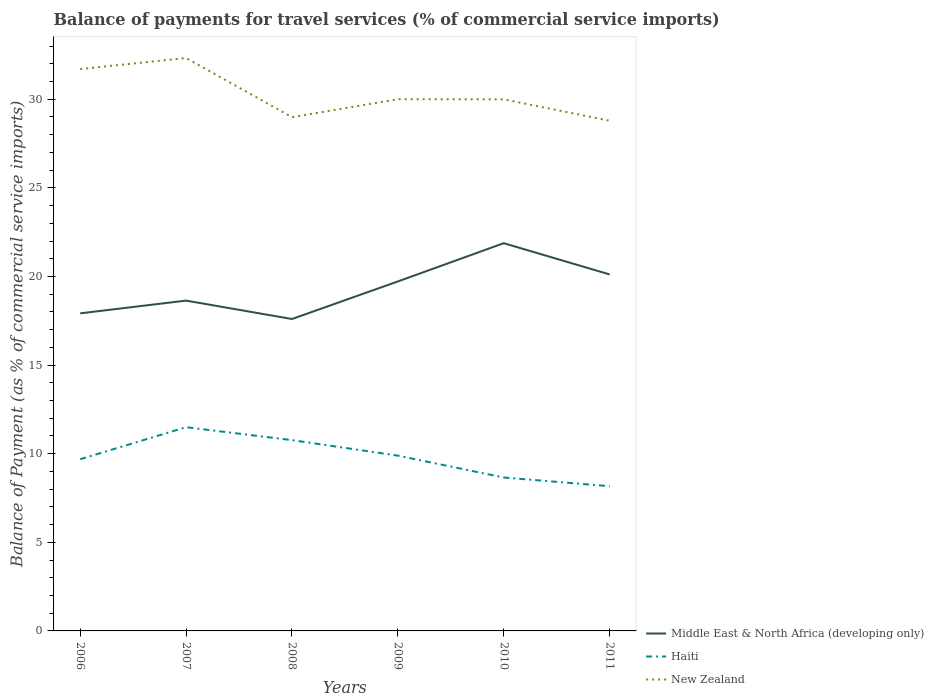How many different coloured lines are there?
Offer a terse response. 3. Is the number of lines equal to the number of legend labels?
Your response must be concise. Yes. Across all years, what is the maximum balance of payments for travel services in New Zealand?
Your answer should be compact. 28.78. What is the total balance of payments for travel services in Haiti in the graph?
Provide a short and direct response. 2.11. What is the difference between the highest and the second highest balance of payments for travel services in New Zealand?
Keep it short and to the point. 3.54. What is the difference between the highest and the lowest balance of payments for travel services in Haiti?
Ensure brevity in your answer.  3. Is the balance of payments for travel services in Haiti strictly greater than the balance of payments for travel services in New Zealand over the years?
Offer a terse response. Yes. How many years are there in the graph?
Make the answer very short. 6. What is the difference between two consecutive major ticks on the Y-axis?
Offer a very short reply. 5. Does the graph contain any zero values?
Your answer should be very brief. No. How many legend labels are there?
Provide a short and direct response. 3. What is the title of the graph?
Your answer should be compact. Balance of payments for travel services (% of commercial service imports). What is the label or title of the Y-axis?
Offer a terse response. Balance of Payment (as % of commercial service imports). What is the Balance of Payment (as % of commercial service imports) of Middle East & North Africa (developing only) in 2006?
Keep it short and to the point. 17.92. What is the Balance of Payment (as % of commercial service imports) in Haiti in 2006?
Your response must be concise. 9.69. What is the Balance of Payment (as % of commercial service imports) in New Zealand in 2006?
Make the answer very short. 31.7. What is the Balance of Payment (as % of commercial service imports) in Middle East & North Africa (developing only) in 2007?
Give a very brief answer. 18.64. What is the Balance of Payment (as % of commercial service imports) of Haiti in 2007?
Your response must be concise. 11.49. What is the Balance of Payment (as % of commercial service imports) of New Zealand in 2007?
Your response must be concise. 32.33. What is the Balance of Payment (as % of commercial service imports) in Middle East & North Africa (developing only) in 2008?
Offer a terse response. 17.6. What is the Balance of Payment (as % of commercial service imports) of Haiti in 2008?
Ensure brevity in your answer.  10.77. What is the Balance of Payment (as % of commercial service imports) of New Zealand in 2008?
Your response must be concise. 28.99. What is the Balance of Payment (as % of commercial service imports) of Middle East & North Africa (developing only) in 2009?
Your answer should be very brief. 19.72. What is the Balance of Payment (as % of commercial service imports) in Haiti in 2009?
Your answer should be compact. 9.89. What is the Balance of Payment (as % of commercial service imports) in New Zealand in 2009?
Make the answer very short. 30. What is the Balance of Payment (as % of commercial service imports) of Middle East & North Africa (developing only) in 2010?
Your answer should be very brief. 21.88. What is the Balance of Payment (as % of commercial service imports) in Haiti in 2010?
Provide a succinct answer. 8.66. What is the Balance of Payment (as % of commercial service imports) in New Zealand in 2010?
Your response must be concise. 29.99. What is the Balance of Payment (as % of commercial service imports) in Middle East & North Africa (developing only) in 2011?
Keep it short and to the point. 20.11. What is the Balance of Payment (as % of commercial service imports) of Haiti in 2011?
Make the answer very short. 8.16. What is the Balance of Payment (as % of commercial service imports) of New Zealand in 2011?
Your answer should be compact. 28.78. Across all years, what is the maximum Balance of Payment (as % of commercial service imports) in Middle East & North Africa (developing only)?
Give a very brief answer. 21.88. Across all years, what is the maximum Balance of Payment (as % of commercial service imports) of Haiti?
Offer a terse response. 11.49. Across all years, what is the maximum Balance of Payment (as % of commercial service imports) of New Zealand?
Offer a very short reply. 32.33. Across all years, what is the minimum Balance of Payment (as % of commercial service imports) in Middle East & North Africa (developing only)?
Offer a terse response. 17.6. Across all years, what is the minimum Balance of Payment (as % of commercial service imports) in Haiti?
Provide a short and direct response. 8.16. Across all years, what is the minimum Balance of Payment (as % of commercial service imports) of New Zealand?
Make the answer very short. 28.78. What is the total Balance of Payment (as % of commercial service imports) of Middle East & North Africa (developing only) in the graph?
Offer a terse response. 115.86. What is the total Balance of Payment (as % of commercial service imports) of Haiti in the graph?
Ensure brevity in your answer.  58.66. What is the total Balance of Payment (as % of commercial service imports) in New Zealand in the graph?
Your answer should be very brief. 181.79. What is the difference between the Balance of Payment (as % of commercial service imports) in Middle East & North Africa (developing only) in 2006 and that in 2007?
Ensure brevity in your answer.  -0.72. What is the difference between the Balance of Payment (as % of commercial service imports) of Haiti in 2006 and that in 2007?
Your answer should be very brief. -1.81. What is the difference between the Balance of Payment (as % of commercial service imports) in New Zealand in 2006 and that in 2007?
Your answer should be compact. -0.63. What is the difference between the Balance of Payment (as % of commercial service imports) of Middle East & North Africa (developing only) in 2006 and that in 2008?
Offer a terse response. 0.32. What is the difference between the Balance of Payment (as % of commercial service imports) of Haiti in 2006 and that in 2008?
Your answer should be compact. -1.08. What is the difference between the Balance of Payment (as % of commercial service imports) in New Zealand in 2006 and that in 2008?
Provide a short and direct response. 2.71. What is the difference between the Balance of Payment (as % of commercial service imports) in Middle East & North Africa (developing only) in 2006 and that in 2009?
Your answer should be compact. -1.8. What is the difference between the Balance of Payment (as % of commercial service imports) of Haiti in 2006 and that in 2009?
Provide a succinct answer. -0.2. What is the difference between the Balance of Payment (as % of commercial service imports) in New Zealand in 2006 and that in 2009?
Offer a very short reply. 1.7. What is the difference between the Balance of Payment (as % of commercial service imports) in Middle East & North Africa (developing only) in 2006 and that in 2010?
Your answer should be compact. -3.96. What is the difference between the Balance of Payment (as % of commercial service imports) in Haiti in 2006 and that in 2010?
Offer a terse response. 1.03. What is the difference between the Balance of Payment (as % of commercial service imports) of New Zealand in 2006 and that in 2010?
Give a very brief answer. 1.71. What is the difference between the Balance of Payment (as % of commercial service imports) of Middle East & North Africa (developing only) in 2006 and that in 2011?
Offer a very short reply. -2.19. What is the difference between the Balance of Payment (as % of commercial service imports) in Haiti in 2006 and that in 2011?
Offer a terse response. 1.52. What is the difference between the Balance of Payment (as % of commercial service imports) in New Zealand in 2006 and that in 2011?
Your answer should be compact. 2.92. What is the difference between the Balance of Payment (as % of commercial service imports) of Middle East & North Africa (developing only) in 2007 and that in 2008?
Your answer should be very brief. 1.04. What is the difference between the Balance of Payment (as % of commercial service imports) of Haiti in 2007 and that in 2008?
Your response must be concise. 0.73. What is the difference between the Balance of Payment (as % of commercial service imports) in New Zealand in 2007 and that in 2008?
Offer a terse response. 3.34. What is the difference between the Balance of Payment (as % of commercial service imports) in Middle East & North Africa (developing only) in 2007 and that in 2009?
Your answer should be very brief. -1.08. What is the difference between the Balance of Payment (as % of commercial service imports) in Haiti in 2007 and that in 2009?
Keep it short and to the point. 1.6. What is the difference between the Balance of Payment (as % of commercial service imports) in New Zealand in 2007 and that in 2009?
Your answer should be very brief. 2.33. What is the difference between the Balance of Payment (as % of commercial service imports) of Middle East & North Africa (developing only) in 2007 and that in 2010?
Keep it short and to the point. -3.24. What is the difference between the Balance of Payment (as % of commercial service imports) in Haiti in 2007 and that in 2010?
Offer a terse response. 2.84. What is the difference between the Balance of Payment (as % of commercial service imports) of New Zealand in 2007 and that in 2010?
Keep it short and to the point. 2.33. What is the difference between the Balance of Payment (as % of commercial service imports) in Middle East & North Africa (developing only) in 2007 and that in 2011?
Make the answer very short. -1.48. What is the difference between the Balance of Payment (as % of commercial service imports) in Haiti in 2007 and that in 2011?
Give a very brief answer. 3.33. What is the difference between the Balance of Payment (as % of commercial service imports) of New Zealand in 2007 and that in 2011?
Offer a very short reply. 3.54. What is the difference between the Balance of Payment (as % of commercial service imports) in Middle East & North Africa (developing only) in 2008 and that in 2009?
Ensure brevity in your answer.  -2.12. What is the difference between the Balance of Payment (as % of commercial service imports) of Haiti in 2008 and that in 2009?
Your answer should be very brief. 0.88. What is the difference between the Balance of Payment (as % of commercial service imports) of New Zealand in 2008 and that in 2009?
Provide a short and direct response. -1.01. What is the difference between the Balance of Payment (as % of commercial service imports) of Middle East & North Africa (developing only) in 2008 and that in 2010?
Offer a terse response. -4.28. What is the difference between the Balance of Payment (as % of commercial service imports) of Haiti in 2008 and that in 2010?
Offer a terse response. 2.11. What is the difference between the Balance of Payment (as % of commercial service imports) of New Zealand in 2008 and that in 2010?
Make the answer very short. -1.01. What is the difference between the Balance of Payment (as % of commercial service imports) in Middle East & North Africa (developing only) in 2008 and that in 2011?
Make the answer very short. -2.51. What is the difference between the Balance of Payment (as % of commercial service imports) of Haiti in 2008 and that in 2011?
Your answer should be compact. 2.6. What is the difference between the Balance of Payment (as % of commercial service imports) of New Zealand in 2008 and that in 2011?
Give a very brief answer. 0.2. What is the difference between the Balance of Payment (as % of commercial service imports) in Middle East & North Africa (developing only) in 2009 and that in 2010?
Your answer should be very brief. -2.16. What is the difference between the Balance of Payment (as % of commercial service imports) of Haiti in 2009 and that in 2010?
Make the answer very short. 1.23. What is the difference between the Balance of Payment (as % of commercial service imports) of New Zealand in 2009 and that in 2010?
Ensure brevity in your answer.  0.01. What is the difference between the Balance of Payment (as % of commercial service imports) in Middle East & North Africa (developing only) in 2009 and that in 2011?
Make the answer very short. -0.4. What is the difference between the Balance of Payment (as % of commercial service imports) of Haiti in 2009 and that in 2011?
Your response must be concise. 1.73. What is the difference between the Balance of Payment (as % of commercial service imports) of New Zealand in 2009 and that in 2011?
Your answer should be very brief. 1.22. What is the difference between the Balance of Payment (as % of commercial service imports) of Middle East & North Africa (developing only) in 2010 and that in 2011?
Your response must be concise. 1.76. What is the difference between the Balance of Payment (as % of commercial service imports) in Haiti in 2010 and that in 2011?
Offer a very short reply. 0.49. What is the difference between the Balance of Payment (as % of commercial service imports) of New Zealand in 2010 and that in 2011?
Offer a terse response. 1.21. What is the difference between the Balance of Payment (as % of commercial service imports) in Middle East & North Africa (developing only) in 2006 and the Balance of Payment (as % of commercial service imports) in Haiti in 2007?
Your answer should be very brief. 6.42. What is the difference between the Balance of Payment (as % of commercial service imports) in Middle East & North Africa (developing only) in 2006 and the Balance of Payment (as % of commercial service imports) in New Zealand in 2007?
Keep it short and to the point. -14.41. What is the difference between the Balance of Payment (as % of commercial service imports) of Haiti in 2006 and the Balance of Payment (as % of commercial service imports) of New Zealand in 2007?
Your response must be concise. -22.64. What is the difference between the Balance of Payment (as % of commercial service imports) of Middle East & North Africa (developing only) in 2006 and the Balance of Payment (as % of commercial service imports) of Haiti in 2008?
Keep it short and to the point. 7.15. What is the difference between the Balance of Payment (as % of commercial service imports) in Middle East & North Africa (developing only) in 2006 and the Balance of Payment (as % of commercial service imports) in New Zealand in 2008?
Offer a terse response. -11.07. What is the difference between the Balance of Payment (as % of commercial service imports) in Haiti in 2006 and the Balance of Payment (as % of commercial service imports) in New Zealand in 2008?
Ensure brevity in your answer.  -19.3. What is the difference between the Balance of Payment (as % of commercial service imports) of Middle East & North Africa (developing only) in 2006 and the Balance of Payment (as % of commercial service imports) of Haiti in 2009?
Offer a terse response. 8.03. What is the difference between the Balance of Payment (as % of commercial service imports) of Middle East & North Africa (developing only) in 2006 and the Balance of Payment (as % of commercial service imports) of New Zealand in 2009?
Keep it short and to the point. -12.08. What is the difference between the Balance of Payment (as % of commercial service imports) of Haiti in 2006 and the Balance of Payment (as % of commercial service imports) of New Zealand in 2009?
Your response must be concise. -20.31. What is the difference between the Balance of Payment (as % of commercial service imports) of Middle East & North Africa (developing only) in 2006 and the Balance of Payment (as % of commercial service imports) of Haiti in 2010?
Give a very brief answer. 9.26. What is the difference between the Balance of Payment (as % of commercial service imports) of Middle East & North Africa (developing only) in 2006 and the Balance of Payment (as % of commercial service imports) of New Zealand in 2010?
Your answer should be compact. -12.07. What is the difference between the Balance of Payment (as % of commercial service imports) in Haiti in 2006 and the Balance of Payment (as % of commercial service imports) in New Zealand in 2010?
Your answer should be very brief. -20.3. What is the difference between the Balance of Payment (as % of commercial service imports) of Middle East & North Africa (developing only) in 2006 and the Balance of Payment (as % of commercial service imports) of Haiti in 2011?
Provide a succinct answer. 9.75. What is the difference between the Balance of Payment (as % of commercial service imports) in Middle East & North Africa (developing only) in 2006 and the Balance of Payment (as % of commercial service imports) in New Zealand in 2011?
Make the answer very short. -10.87. What is the difference between the Balance of Payment (as % of commercial service imports) of Haiti in 2006 and the Balance of Payment (as % of commercial service imports) of New Zealand in 2011?
Your answer should be very brief. -19.1. What is the difference between the Balance of Payment (as % of commercial service imports) in Middle East & North Africa (developing only) in 2007 and the Balance of Payment (as % of commercial service imports) in Haiti in 2008?
Give a very brief answer. 7.87. What is the difference between the Balance of Payment (as % of commercial service imports) of Middle East & North Africa (developing only) in 2007 and the Balance of Payment (as % of commercial service imports) of New Zealand in 2008?
Give a very brief answer. -10.35. What is the difference between the Balance of Payment (as % of commercial service imports) of Haiti in 2007 and the Balance of Payment (as % of commercial service imports) of New Zealand in 2008?
Your answer should be compact. -17.49. What is the difference between the Balance of Payment (as % of commercial service imports) of Middle East & North Africa (developing only) in 2007 and the Balance of Payment (as % of commercial service imports) of Haiti in 2009?
Keep it short and to the point. 8.75. What is the difference between the Balance of Payment (as % of commercial service imports) in Middle East & North Africa (developing only) in 2007 and the Balance of Payment (as % of commercial service imports) in New Zealand in 2009?
Ensure brevity in your answer.  -11.36. What is the difference between the Balance of Payment (as % of commercial service imports) in Haiti in 2007 and the Balance of Payment (as % of commercial service imports) in New Zealand in 2009?
Make the answer very short. -18.51. What is the difference between the Balance of Payment (as % of commercial service imports) in Middle East & North Africa (developing only) in 2007 and the Balance of Payment (as % of commercial service imports) in Haiti in 2010?
Your response must be concise. 9.98. What is the difference between the Balance of Payment (as % of commercial service imports) of Middle East & North Africa (developing only) in 2007 and the Balance of Payment (as % of commercial service imports) of New Zealand in 2010?
Offer a terse response. -11.36. What is the difference between the Balance of Payment (as % of commercial service imports) in Haiti in 2007 and the Balance of Payment (as % of commercial service imports) in New Zealand in 2010?
Your response must be concise. -18.5. What is the difference between the Balance of Payment (as % of commercial service imports) of Middle East & North Africa (developing only) in 2007 and the Balance of Payment (as % of commercial service imports) of Haiti in 2011?
Your answer should be very brief. 10.47. What is the difference between the Balance of Payment (as % of commercial service imports) in Middle East & North Africa (developing only) in 2007 and the Balance of Payment (as % of commercial service imports) in New Zealand in 2011?
Give a very brief answer. -10.15. What is the difference between the Balance of Payment (as % of commercial service imports) of Haiti in 2007 and the Balance of Payment (as % of commercial service imports) of New Zealand in 2011?
Provide a succinct answer. -17.29. What is the difference between the Balance of Payment (as % of commercial service imports) in Middle East & North Africa (developing only) in 2008 and the Balance of Payment (as % of commercial service imports) in Haiti in 2009?
Offer a terse response. 7.71. What is the difference between the Balance of Payment (as % of commercial service imports) of Middle East & North Africa (developing only) in 2008 and the Balance of Payment (as % of commercial service imports) of New Zealand in 2009?
Provide a short and direct response. -12.4. What is the difference between the Balance of Payment (as % of commercial service imports) in Haiti in 2008 and the Balance of Payment (as % of commercial service imports) in New Zealand in 2009?
Give a very brief answer. -19.23. What is the difference between the Balance of Payment (as % of commercial service imports) of Middle East & North Africa (developing only) in 2008 and the Balance of Payment (as % of commercial service imports) of Haiti in 2010?
Make the answer very short. 8.94. What is the difference between the Balance of Payment (as % of commercial service imports) of Middle East & North Africa (developing only) in 2008 and the Balance of Payment (as % of commercial service imports) of New Zealand in 2010?
Give a very brief answer. -12.39. What is the difference between the Balance of Payment (as % of commercial service imports) of Haiti in 2008 and the Balance of Payment (as % of commercial service imports) of New Zealand in 2010?
Ensure brevity in your answer.  -19.23. What is the difference between the Balance of Payment (as % of commercial service imports) in Middle East & North Africa (developing only) in 2008 and the Balance of Payment (as % of commercial service imports) in Haiti in 2011?
Offer a terse response. 9.43. What is the difference between the Balance of Payment (as % of commercial service imports) in Middle East & North Africa (developing only) in 2008 and the Balance of Payment (as % of commercial service imports) in New Zealand in 2011?
Ensure brevity in your answer.  -11.19. What is the difference between the Balance of Payment (as % of commercial service imports) in Haiti in 2008 and the Balance of Payment (as % of commercial service imports) in New Zealand in 2011?
Your response must be concise. -18.02. What is the difference between the Balance of Payment (as % of commercial service imports) of Middle East & North Africa (developing only) in 2009 and the Balance of Payment (as % of commercial service imports) of Haiti in 2010?
Ensure brevity in your answer.  11.06. What is the difference between the Balance of Payment (as % of commercial service imports) of Middle East & North Africa (developing only) in 2009 and the Balance of Payment (as % of commercial service imports) of New Zealand in 2010?
Ensure brevity in your answer.  -10.27. What is the difference between the Balance of Payment (as % of commercial service imports) of Haiti in 2009 and the Balance of Payment (as % of commercial service imports) of New Zealand in 2010?
Provide a short and direct response. -20.1. What is the difference between the Balance of Payment (as % of commercial service imports) of Middle East & North Africa (developing only) in 2009 and the Balance of Payment (as % of commercial service imports) of Haiti in 2011?
Keep it short and to the point. 11.55. What is the difference between the Balance of Payment (as % of commercial service imports) in Middle East & North Africa (developing only) in 2009 and the Balance of Payment (as % of commercial service imports) in New Zealand in 2011?
Provide a succinct answer. -9.07. What is the difference between the Balance of Payment (as % of commercial service imports) of Haiti in 2009 and the Balance of Payment (as % of commercial service imports) of New Zealand in 2011?
Keep it short and to the point. -18.89. What is the difference between the Balance of Payment (as % of commercial service imports) in Middle East & North Africa (developing only) in 2010 and the Balance of Payment (as % of commercial service imports) in Haiti in 2011?
Make the answer very short. 13.71. What is the difference between the Balance of Payment (as % of commercial service imports) of Middle East & North Africa (developing only) in 2010 and the Balance of Payment (as % of commercial service imports) of New Zealand in 2011?
Keep it short and to the point. -6.91. What is the difference between the Balance of Payment (as % of commercial service imports) of Haiti in 2010 and the Balance of Payment (as % of commercial service imports) of New Zealand in 2011?
Your answer should be compact. -20.13. What is the average Balance of Payment (as % of commercial service imports) in Middle East & North Africa (developing only) per year?
Make the answer very short. 19.31. What is the average Balance of Payment (as % of commercial service imports) of Haiti per year?
Your answer should be very brief. 9.78. What is the average Balance of Payment (as % of commercial service imports) in New Zealand per year?
Your answer should be compact. 30.3. In the year 2006, what is the difference between the Balance of Payment (as % of commercial service imports) in Middle East & North Africa (developing only) and Balance of Payment (as % of commercial service imports) in Haiti?
Ensure brevity in your answer.  8.23. In the year 2006, what is the difference between the Balance of Payment (as % of commercial service imports) in Middle East & North Africa (developing only) and Balance of Payment (as % of commercial service imports) in New Zealand?
Make the answer very short. -13.78. In the year 2006, what is the difference between the Balance of Payment (as % of commercial service imports) of Haiti and Balance of Payment (as % of commercial service imports) of New Zealand?
Keep it short and to the point. -22.01. In the year 2007, what is the difference between the Balance of Payment (as % of commercial service imports) in Middle East & North Africa (developing only) and Balance of Payment (as % of commercial service imports) in Haiti?
Offer a terse response. 7.14. In the year 2007, what is the difference between the Balance of Payment (as % of commercial service imports) of Middle East & North Africa (developing only) and Balance of Payment (as % of commercial service imports) of New Zealand?
Offer a terse response. -13.69. In the year 2007, what is the difference between the Balance of Payment (as % of commercial service imports) of Haiti and Balance of Payment (as % of commercial service imports) of New Zealand?
Make the answer very short. -20.83. In the year 2008, what is the difference between the Balance of Payment (as % of commercial service imports) of Middle East & North Africa (developing only) and Balance of Payment (as % of commercial service imports) of Haiti?
Provide a succinct answer. 6.83. In the year 2008, what is the difference between the Balance of Payment (as % of commercial service imports) of Middle East & North Africa (developing only) and Balance of Payment (as % of commercial service imports) of New Zealand?
Ensure brevity in your answer.  -11.39. In the year 2008, what is the difference between the Balance of Payment (as % of commercial service imports) in Haiti and Balance of Payment (as % of commercial service imports) in New Zealand?
Ensure brevity in your answer.  -18.22. In the year 2009, what is the difference between the Balance of Payment (as % of commercial service imports) of Middle East & North Africa (developing only) and Balance of Payment (as % of commercial service imports) of Haiti?
Your answer should be very brief. 9.83. In the year 2009, what is the difference between the Balance of Payment (as % of commercial service imports) in Middle East & North Africa (developing only) and Balance of Payment (as % of commercial service imports) in New Zealand?
Keep it short and to the point. -10.28. In the year 2009, what is the difference between the Balance of Payment (as % of commercial service imports) of Haiti and Balance of Payment (as % of commercial service imports) of New Zealand?
Keep it short and to the point. -20.11. In the year 2010, what is the difference between the Balance of Payment (as % of commercial service imports) in Middle East & North Africa (developing only) and Balance of Payment (as % of commercial service imports) in Haiti?
Your answer should be compact. 13.22. In the year 2010, what is the difference between the Balance of Payment (as % of commercial service imports) of Middle East & North Africa (developing only) and Balance of Payment (as % of commercial service imports) of New Zealand?
Your response must be concise. -8.12. In the year 2010, what is the difference between the Balance of Payment (as % of commercial service imports) in Haiti and Balance of Payment (as % of commercial service imports) in New Zealand?
Make the answer very short. -21.34. In the year 2011, what is the difference between the Balance of Payment (as % of commercial service imports) of Middle East & North Africa (developing only) and Balance of Payment (as % of commercial service imports) of Haiti?
Your answer should be compact. 11.95. In the year 2011, what is the difference between the Balance of Payment (as % of commercial service imports) in Middle East & North Africa (developing only) and Balance of Payment (as % of commercial service imports) in New Zealand?
Your answer should be very brief. -8.67. In the year 2011, what is the difference between the Balance of Payment (as % of commercial service imports) of Haiti and Balance of Payment (as % of commercial service imports) of New Zealand?
Your answer should be compact. -20.62. What is the ratio of the Balance of Payment (as % of commercial service imports) of Middle East & North Africa (developing only) in 2006 to that in 2007?
Ensure brevity in your answer.  0.96. What is the ratio of the Balance of Payment (as % of commercial service imports) of Haiti in 2006 to that in 2007?
Your response must be concise. 0.84. What is the ratio of the Balance of Payment (as % of commercial service imports) in New Zealand in 2006 to that in 2007?
Keep it short and to the point. 0.98. What is the ratio of the Balance of Payment (as % of commercial service imports) in Middle East & North Africa (developing only) in 2006 to that in 2008?
Offer a terse response. 1.02. What is the ratio of the Balance of Payment (as % of commercial service imports) in Haiti in 2006 to that in 2008?
Provide a succinct answer. 0.9. What is the ratio of the Balance of Payment (as % of commercial service imports) of New Zealand in 2006 to that in 2008?
Your answer should be compact. 1.09. What is the ratio of the Balance of Payment (as % of commercial service imports) of Middle East & North Africa (developing only) in 2006 to that in 2009?
Your answer should be compact. 0.91. What is the ratio of the Balance of Payment (as % of commercial service imports) in Haiti in 2006 to that in 2009?
Offer a terse response. 0.98. What is the ratio of the Balance of Payment (as % of commercial service imports) in New Zealand in 2006 to that in 2009?
Provide a succinct answer. 1.06. What is the ratio of the Balance of Payment (as % of commercial service imports) in Middle East & North Africa (developing only) in 2006 to that in 2010?
Offer a very short reply. 0.82. What is the ratio of the Balance of Payment (as % of commercial service imports) in Haiti in 2006 to that in 2010?
Offer a terse response. 1.12. What is the ratio of the Balance of Payment (as % of commercial service imports) of New Zealand in 2006 to that in 2010?
Ensure brevity in your answer.  1.06. What is the ratio of the Balance of Payment (as % of commercial service imports) in Middle East & North Africa (developing only) in 2006 to that in 2011?
Keep it short and to the point. 0.89. What is the ratio of the Balance of Payment (as % of commercial service imports) in Haiti in 2006 to that in 2011?
Offer a terse response. 1.19. What is the ratio of the Balance of Payment (as % of commercial service imports) in New Zealand in 2006 to that in 2011?
Ensure brevity in your answer.  1.1. What is the ratio of the Balance of Payment (as % of commercial service imports) in Middle East & North Africa (developing only) in 2007 to that in 2008?
Your answer should be compact. 1.06. What is the ratio of the Balance of Payment (as % of commercial service imports) of Haiti in 2007 to that in 2008?
Offer a terse response. 1.07. What is the ratio of the Balance of Payment (as % of commercial service imports) of New Zealand in 2007 to that in 2008?
Offer a terse response. 1.12. What is the ratio of the Balance of Payment (as % of commercial service imports) in Middle East & North Africa (developing only) in 2007 to that in 2009?
Give a very brief answer. 0.95. What is the ratio of the Balance of Payment (as % of commercial service imports) of Haiti in 2007 to that in 2009?
Keep it short and to the point. 1.16. What is the ratio of the Balance of Payment (as % of commercial service imports) of New Zealand in 2007 to that in 2009?
Keep it short and to the point. 1.08. What is the ratio of the Balance of Payment (as % of commercial service imports) in Middle East & North Africa (developing only) in 2007 to that in 2010?
Offer a terse response. 0.85. What is the ratio of the Balance of Payment (as % of commercial service imports) of Haiti in 2007 to that in 2010?
Keep it short and to the point. 1.33. What is the ratio of the Balance of Payment (as % of commercial service imports) in New Zealand in 2007 to that in 2010?
Your answer should be very brief. 1.08. What is the ratio of the Balance of Payment (as % of commercial service imports) in Middle East & North Africa (developing only) in 2007 to that in 2011?
Offer a terse response. 0.93. What is the ratio of the Balance of Payment (as % of commercial service imports) of Haiti in 2007 to that in 2011?
Make the answer very short. 1.41. What is the ratio of the Balance of Payment (as % of commercial service imports) in New Zealand in 2007 to that in 2011?
Keep it short and to the point. 1.12. What is the ratio of the Balance of Payment (as % of commercial service imports) in Middle East & North Africa (developing only) in 2008 to that in 2009?
Provide a short and direct response. 0.89. What is the ratio of the Balance of Payment (as % of commercial service imports) in Haiti in 2008 to that in 2009?
Your answer should be very brief. 1.09. What is the ratio of the Balance of Payment (as % of commercial service imports) in New Zealand in 2008 to that in 2009?
Ensure brevity in your answer.  0.97. What is the ratio of the Balance of Payment (as % of commercial service imports) of Middle East & North Africa (developing only) in 2008 to that in 2010?
Offer a terse response. 0.8. What is the ratio of the Balance of Payment (as % of commercial service imports) of Haiti in 2008 to that in 2010?
Your response must be concise. 1.24. What is the ratio of the Balance of Payment (as % of commercial service imports) of New Zealand in 2008 to that in 2010?
Your response must be concise. 0.97. What is the ratio of the Balance of Payment (as % of commercial service imports) in Haiti in 2008 to that in 2011?
Provide a succinct answer. 1.32. What is the ratio of the Balance of Payment (as % of commercial service imports) of New Zealand in 2008 to that in 2011?
Offer a very short reply. 1.01. What is the ratio of the Balance of Payment (as % of commercial service imports) of Middle East & North Africa (developing only) in 2009 to that in 2010?
Provide a succinct answer. 0.9. What is the ratio of the Balance of Payment (as % of commercial service imports) in Haiti in 2009 to that in 2010?
Your answer should be compact. 1.14. What is the ratio of the Balance of Payment (as % of commercial service imports) in Middle East & North Africa (developing only) in 2009 to that in 2011?
Make the answer very short. 0.98. What is the ratio of the Balance of Payment (as % of commercial service imports) in Haiti in 2009 to that in 2011?
Ensure brevity in your answer.  1.21. What is the ratio of the Balance of Payment (as % of commercial service imports) of New Zealand in 2009 to that in 2011?
Provide a short and direct response. 1.04. What is the ratio of the Balance of Payment (as % of commercial service imports) in Middle East & North Africa (developing only) in 2010 to that in 2011?
Your answer should be very brief. 1.09. What is the ratio of the Balance of Payment (as % of commercial service imports) of Haiti in 2010 to that in 2011?
Offer a very short reply. 1.06. What is the ratio of the Balance of Payment (as % of commercial service imports) in New Zealand in 2010 to that in 2011?
Your response must be concise. 1.04. What is the difference between the highest and the second highest Balance of Payment (as % of commercial service imports) of Middle East & North Africa (developing only)?
Make the answer very short. 1.76. What is the difference between the highest and the second highest Balance of Payment (as % of commercial service imports) in Haiti?
Your answer should be compact. 0.73. What is the difference between the highest and the second highest Balance of Payment (as % of commercial service imports) in New Zealand?
Keep it short and to the point. 0.63. What is the difference between the highest and the lowest Balance of Payment (as % of commercial service imports) in Middle East & North Africa (developing only)?
Your answer should be compact. 4.28. What is the difference between the highest and the lowest Balance of Payment (as % of commercial service imports) in Haiti?
Give a very brief answer. 3.33. What is the difference between the highest and the lowest Balance of Payment (as % of commercial service imports) of New Zealand?
Make the answer very short. 3.54. 